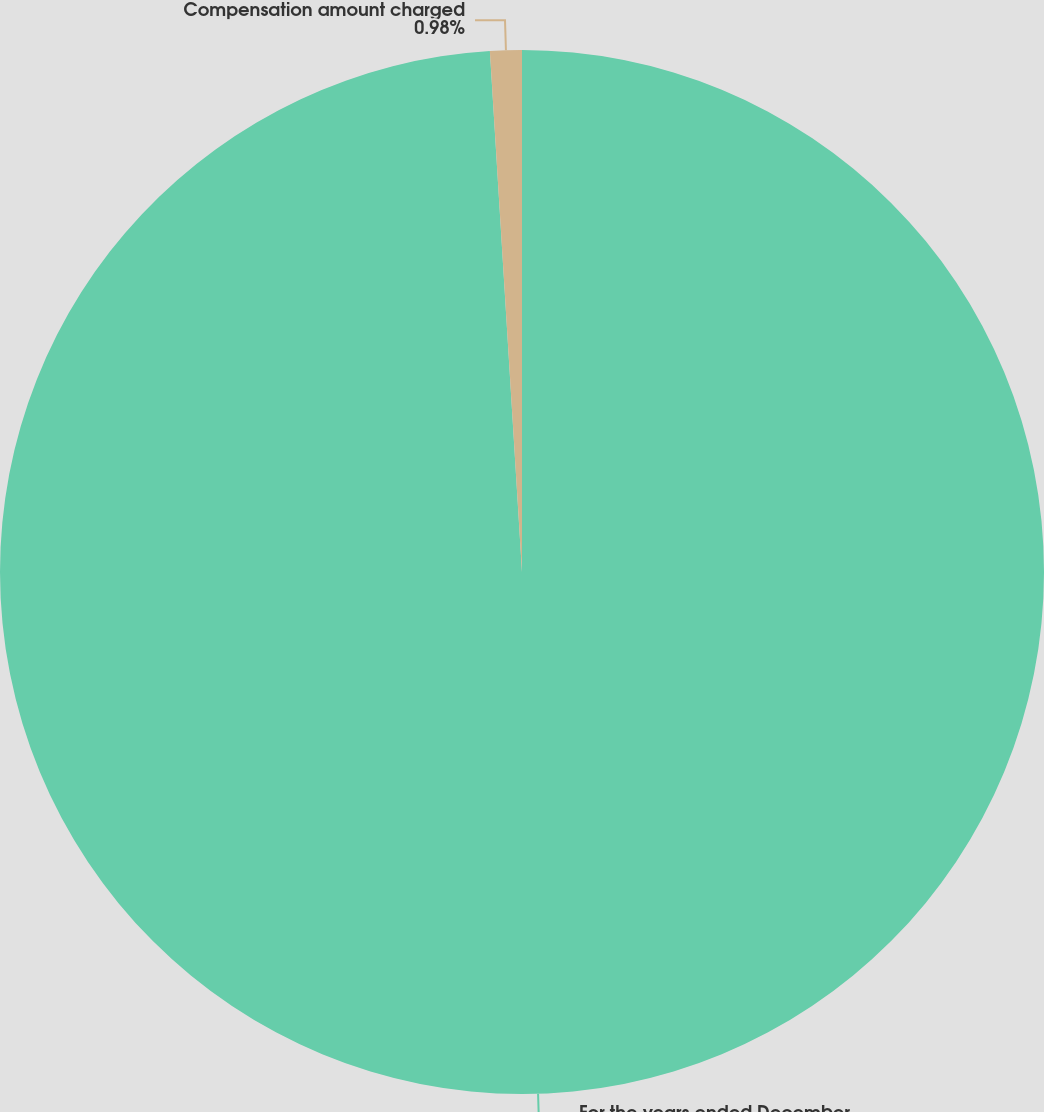Convert chart to OTSL. <chart><loc_0><loc_0><loc_500><loc_500><pie_chart><fcel>For the years ended December<fcel>Compensation amount charged<nl><fcel>99.02%<fcel>0.98%<nl></chart> 